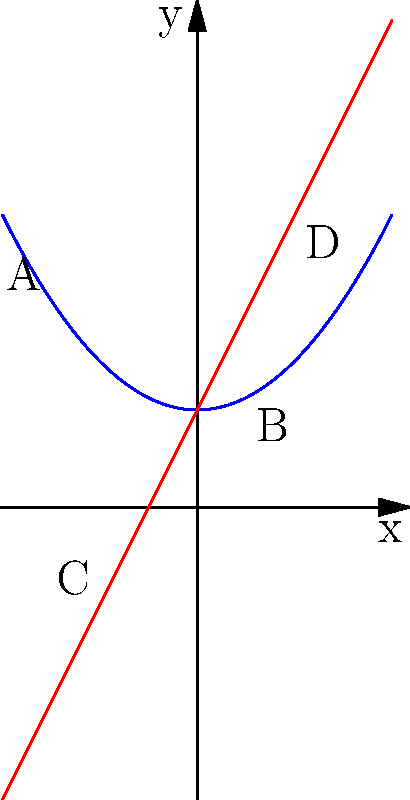Based on the graph showing the relationship between neurotransmitter levels and synaptic plasticity, which of the following statements is most accurate regarding the correlation between these two factors?

A) The relationship is consistently linear
B) There is no correlation
C) The correlation is stronger at higher levels
D) The correlation is non-linear and increases more rapidly at higher levels To analyze the correlation between neurotransmitter levels and synaptic plasticity, we need to examine the graph carefully:

1. The red line represents neurotransmitter levels, which shows a linear increase.
2. The blue curve represents synaptic plasticity, which demonstrates a non-linear, quadratic growth.

3. At lower levels (left side of the graph):
   - The blue curve (synaptic plasticity) increases slowly.
   - The red line (neurotransmitter levels) increases at a constant rate.

4. At higher levels (right side of the graph):
   - The blue curve (synaptic plasticity) increases more rapidly.
   - The red line (neurotransmitter levels) continues to increase at the same constant rate.

5. This indicates that as neurotransmitter levels increase linearly, the corresponding increase in synaptic plasticity becomes more pronounced.

6. The relationship is not consistently linear (ruling out option A), and there is a clear correlation (ruling out option B).

7. The correlation is indeed stronger at higher levels, but this doesn't fully capture the nature of the relationship.

8. The most accurate description is that the correlation is non-linear and increases more rapidly at higher levels, which corresponds to option D.

This non-linear relationship suggests that small changes in neurotransmitter levels at higher concentrations could lead to more significant changes in synaptic plasticity, potentially indicating a threshold effect or a biochemical cascade that becomes more efficient at higher neurotransmitter concentrations.
Answer: D 